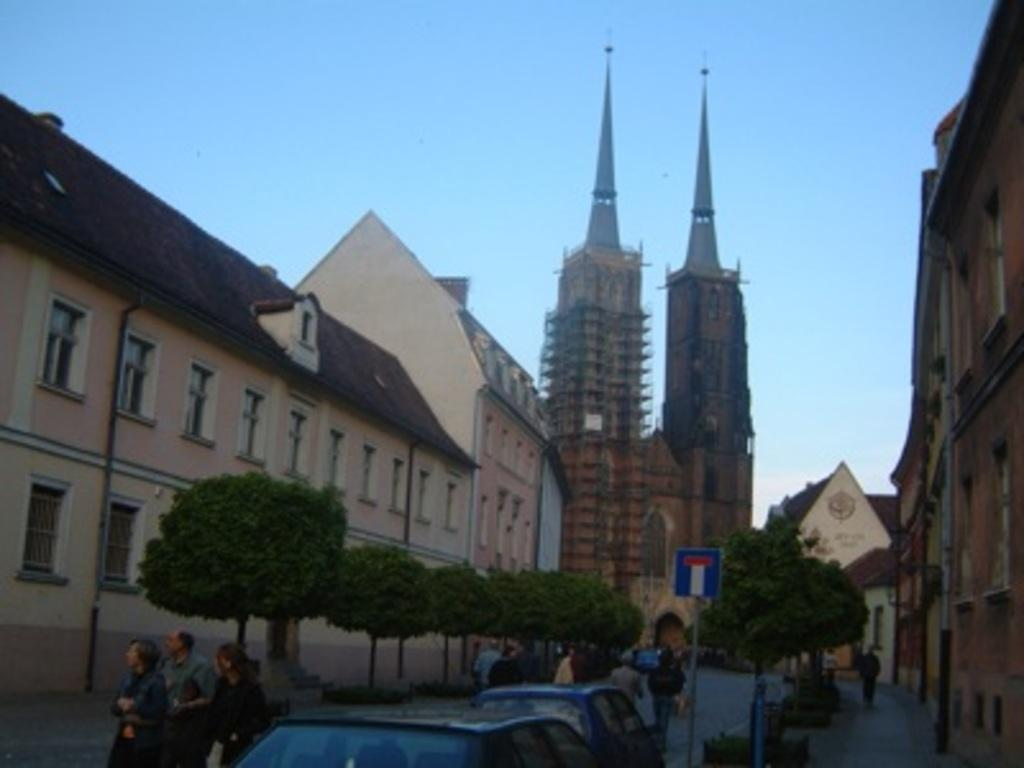What is located in the center of the image? There are buildings in the center of the image. What can be seen at the bottom of the image? At the bottom of the image, there are persons, cars, trees, and boards. What type of pathway is visible at the bottom of the image? A road is visible at the bottom of the image. What is visible at the top of the image? The sky is present at the top of the image. How does the feeling of hope manifest itself in the image? The image does not depict emotions or feelings, so it is not possible to determine how hope might be present. What type of cable can be seen connecting the buildings in the image? There is no cable connecting the buildings in the image; only the buildings themselves are visible. 